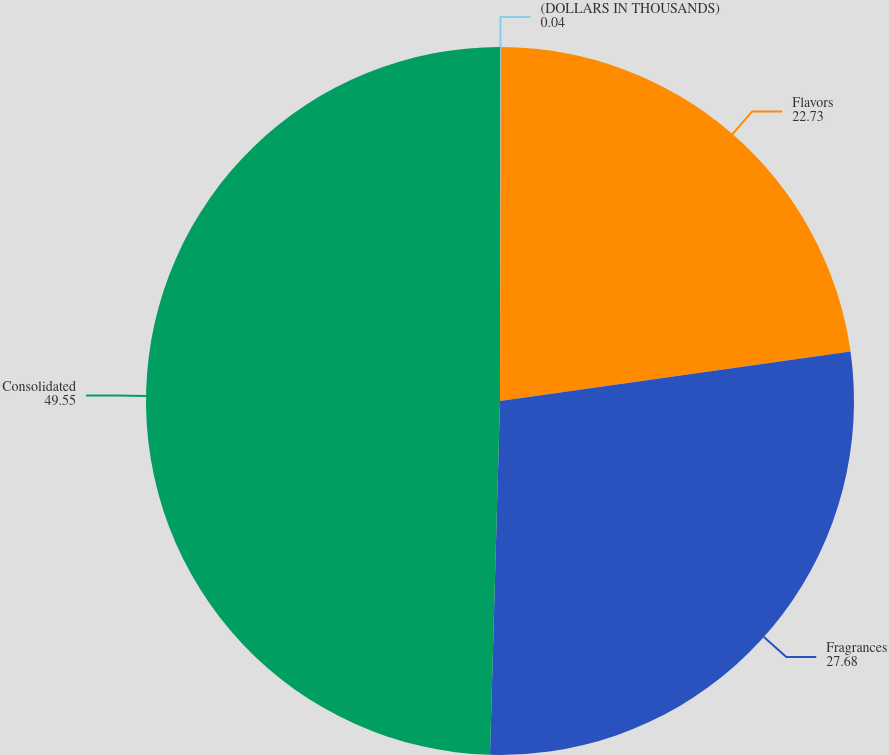Convert chart. <chart><loc_0><loc_0><loc_500><loc_500><pie_chart><fcel>(DOLLARS IN THOUSANDS)<fcel>Flavors<fcel>Fragrances<fcel>Consolidated<nl><fcel>0.04%<fcel>22.73%<fcel>27.68%<fcel>49.55%<nl></chart> 